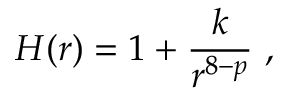<formula> <loc_0><loc_0><loc_500><loc_500>H ( r ) = 1 + \frac { k } { r ^ { 8 - p } } \ ,</formula> 